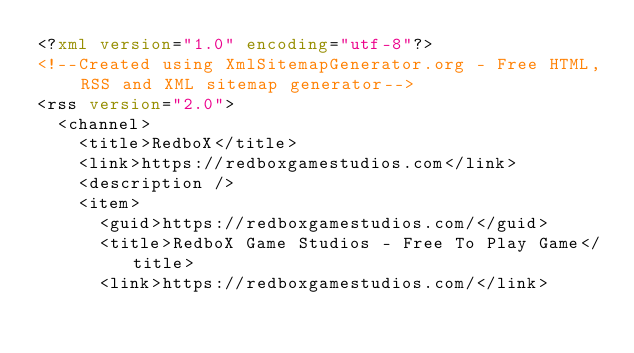Convert code to text. <code><loc_0><loc_0><loc_500><loc_500><_XML_><?xml version="1.0" encoding="utf-8"?>
<!--Created using XmlSitemapGenerator.org - Free HTML, RSS and XML sitemap generator-->
<rss version="2.0">
  <channel>
    <title>RedboX</title>
    <link>https://redboxgamestudios.com</link>
    <description />
    <item>
      <guid>https://redboxgamestudios.com/</guid>
      <title>RedboX Game Studios - Free To Play Game</title>
      <link>https://redboxgamestudios.com/</link></code> 